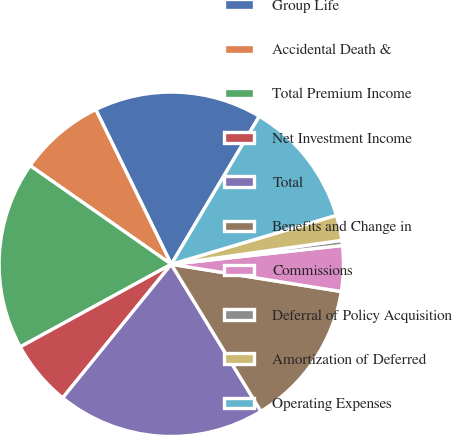<chart> <loc_0><loc_0><loc_500><loc_500><pie_chart><fcel>Group Life<fcel>Accidental Death &<fcel>Total Premium Income<fcel>Net Investment Income<fcel>Total<fcel>Benefits and Change in<fcel>Commissions<fcel>Deferral of Policy Acquisition<fcel>Amortization of Deferred<fcel>Operating Expenses<nl><fcel>15.76%<fcel>8.07%<fcel>17.67%<fcel>6.17%<fcel>19.57%<fcel>13.76%<fcel>4.27%<fcel>0.48%<fcel>2.37%<fcel>11.87%<nl></chart> 